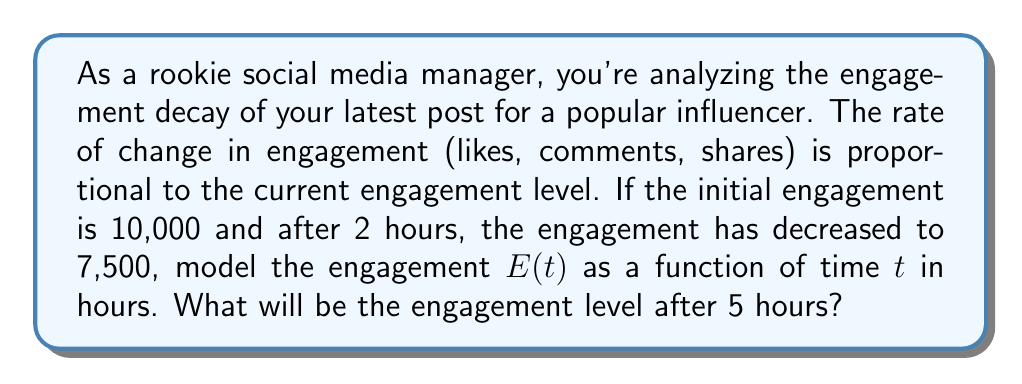Can you answer this question? Let's approach this step-by-step:

1) The rate of change in engagement being proportional to the current engagement level can be modeled by the differential equation:

   $$\frac{dE}{dt} = -kE$$

   where $k$ is a positive constant representing the decay rate.

2) The solution to this differential equation is:

   $$E(t) = E_0e^{-kt}$$

   where $E_0$ is the initial engagement.

3) We're given that $E_0 = 10,000$ and $E(2) = 7,500$. Let's use these to find $k$:

   $$7,500 = 10,000e^{-2k}$$

4) Solving for $k$:

   $$\frac{7,500}{10,000} = e^{-2k}$$
   $$0.75 = e^{-2k}$$
   $$\ln(0.75) = -2k$$
   $$k = -\frac{\ln(0.75)}{2} \approx 0.1438$$

5) Now we have our complete model:

   $$E(t) = 10,000e^{-0.1438t}$$

6) To find the engagement after 5 hours, we simply plug in $t=5$:

   $$E(5) = 10,000e^{-0.1438(5)} \approx 4,884$$

Therefore, after 5 hours, the engagement level will be approximately 4,884.
Answer: $E(5) \approx 4,884$ engagements 